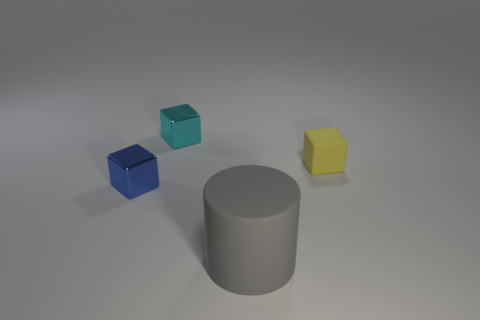Add 2 small blue cubes. How many objects exist? 6 Subtract all cylinders. How many objects are left? 3 Subtract all tiny gray rubber spheres. Subtract all blue blocks. How many objects are left? 3 Add 2 rubber cylinders. How many rubber cylinders are left? 3 Add 3 small red spheres. How many small red spheres exist? 3 Subtract 0 brown spheres. How many objects are left? 4 